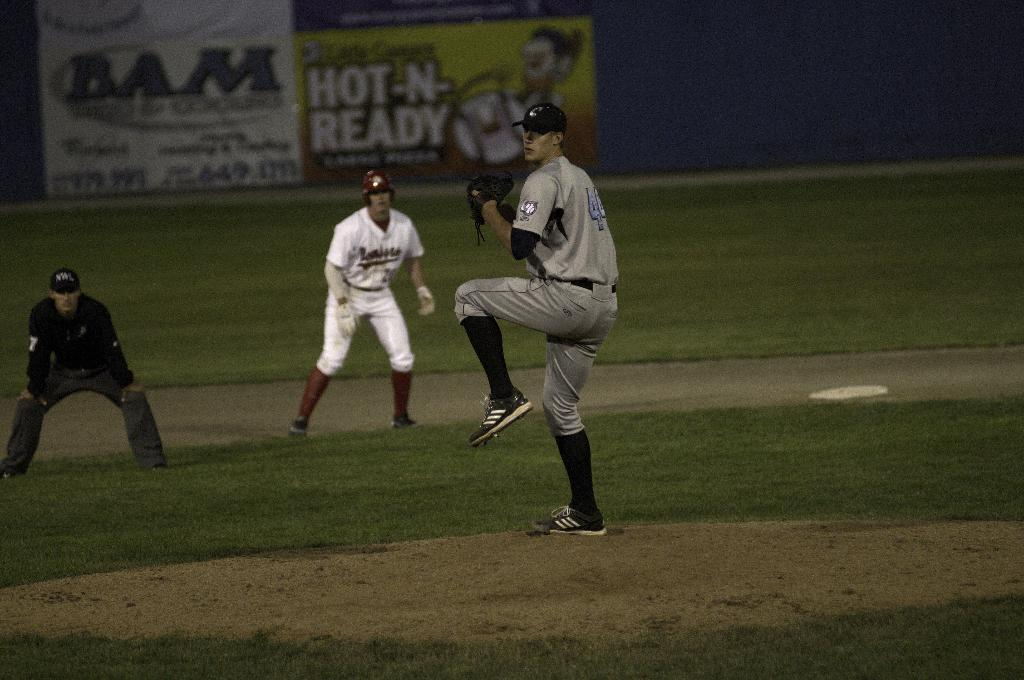Provide a one-sentence caption for the provided image. A baseball game is being played with number forty-four winding up for a pitch. 